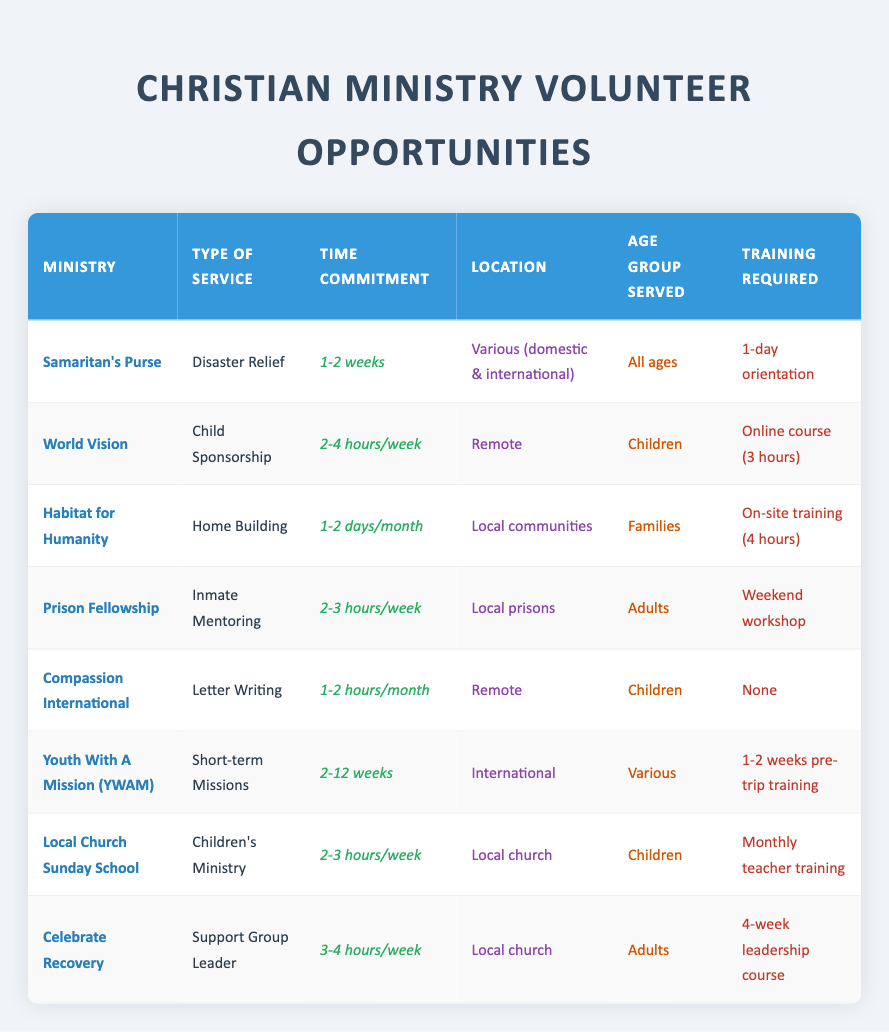What is the time commitment for volunteering with Compassion International? From the table, under the "Time Commitment" column for Compassion International, it states "1-2 hours/month."
Answer: 1-2 hours/month Which ministry requires the most training before starting? By looking at the "Training Required" column, Youth With A Mission (YWAM) requires "1-2 weeks pre-trip training," which is more than others.
Answer: Youth With A Mission (YWAM) How many hours per week do volunteers commit for Celebrate Recovery? In the "Time Commitment" column, Celebrate Recovery is listed as requiring "3-4 hours/week." This is a straightforward retrieval of the information provided.
Answer: 3-4 hours/week Are all the ministries listed serving children? To evaluate this, we can check the "Age Group Served" column. Ministries like World Vision, Compassion International, and Local Church Sunday School serve children, but others like Prison Fellowship and Celebrate Recovery serve adults. Therefore, not all serve children.
Answer: No What is the average time commitment for the ministries that serve adults? The ministries serving adults are Prison Fellowship and Celebrate Recovery. Their respective time commitments are "2-3 hours/week" and "3-4 hours/week." Converting these amounts to hours per week: 2.5 hours for Prison Fellowship and 3.5 hours for Celebrate Recovery. The average is (2.5 + 3.5) / 2 = 3 hours/week.
Answer: 3 hours/week Which ministry offers opportunities for disaster relief and what is the training required? The ministry for disaster relief is Samaritan's Purse, and it requires a "1-day orientation" for training as listed in the respective columns.
Answer: Samaritan's Purse; 1-day orientation What is the difference in time commitment between Habitat for Humanity and Youth With A Mission (YWAM)? Habitat for Humanity has a commitment of "1-2 days/month," while YWAM requires "2-12 weeks." Converting Habitat's commitment to a weekly basis (assuming 1.5 days/month = 6 hours/month which is 1.5 hours/week), thus we compare 1.5 hours/week versus a minimum of about 14 hours/week for YWAM assuming the lowest range of 2 weeks if averaged as hours per week, the difference is significant.
Answer: Approximately 12.5 hours/week more for YWAM Is there a ministry that allows remote volunteering without any training requirements? Checking the table, Compassion International allows remote volunteering and has "None" for training required, meaning no training is necessary to get started.
Answer: Yes, Compassion International 